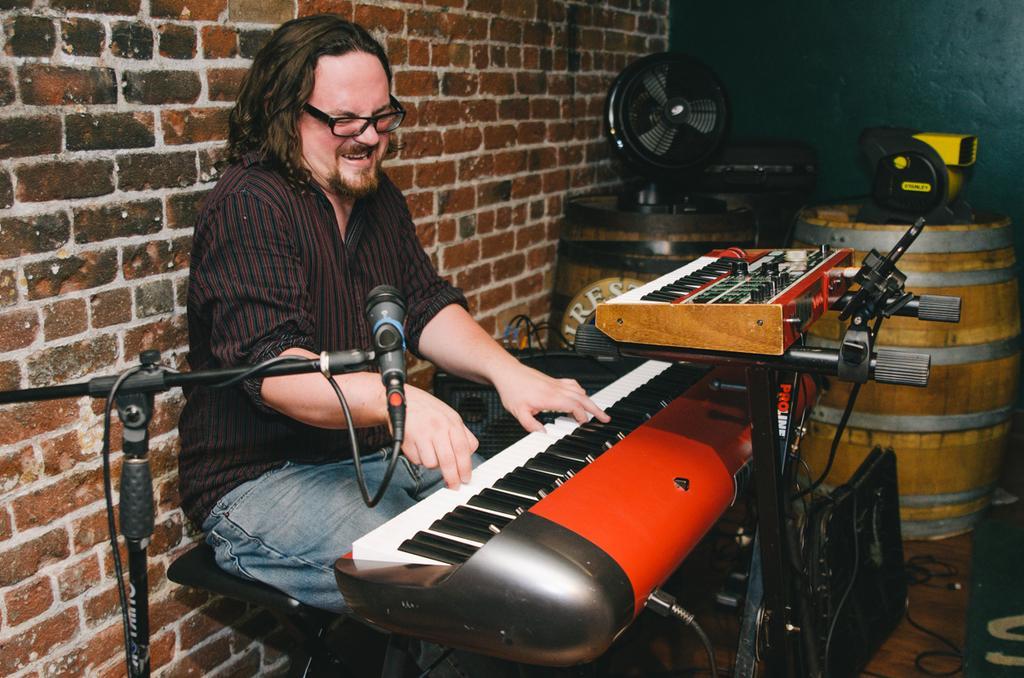Describe this image in one or two sentences. In this image, we can see a man sitting and he is playing a piano, at the left side there is a black color microphone, there are two barrels and there is a fan, we can see a brick wall. 